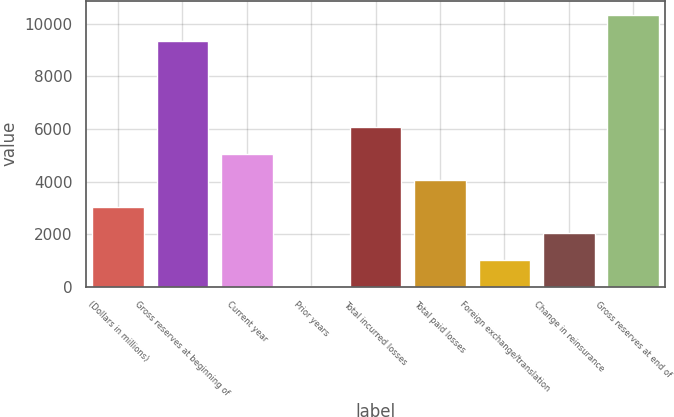<chart> <loc_0><loc_0><loc_500><loc_500><bar_chart><fcel>(Dollars in millions)<fcel>Gross reserves at beginning of<fcel>Current year<fcel>Prior years<fcel>Total incurred losses<fcel>Total paid losses<fcel>Foreign exchange/translation<fcel>Change in reinsurance<fcel>Gross reserves at end of<nl><fcel>3039.55<fcel>9340.2<fcel>5063.45<fcel>3.7<fcel>6075.4<fcel>4051.5<fcel>1015.65<fcel>2027.6<fcel>10352.1<nl></chart> 